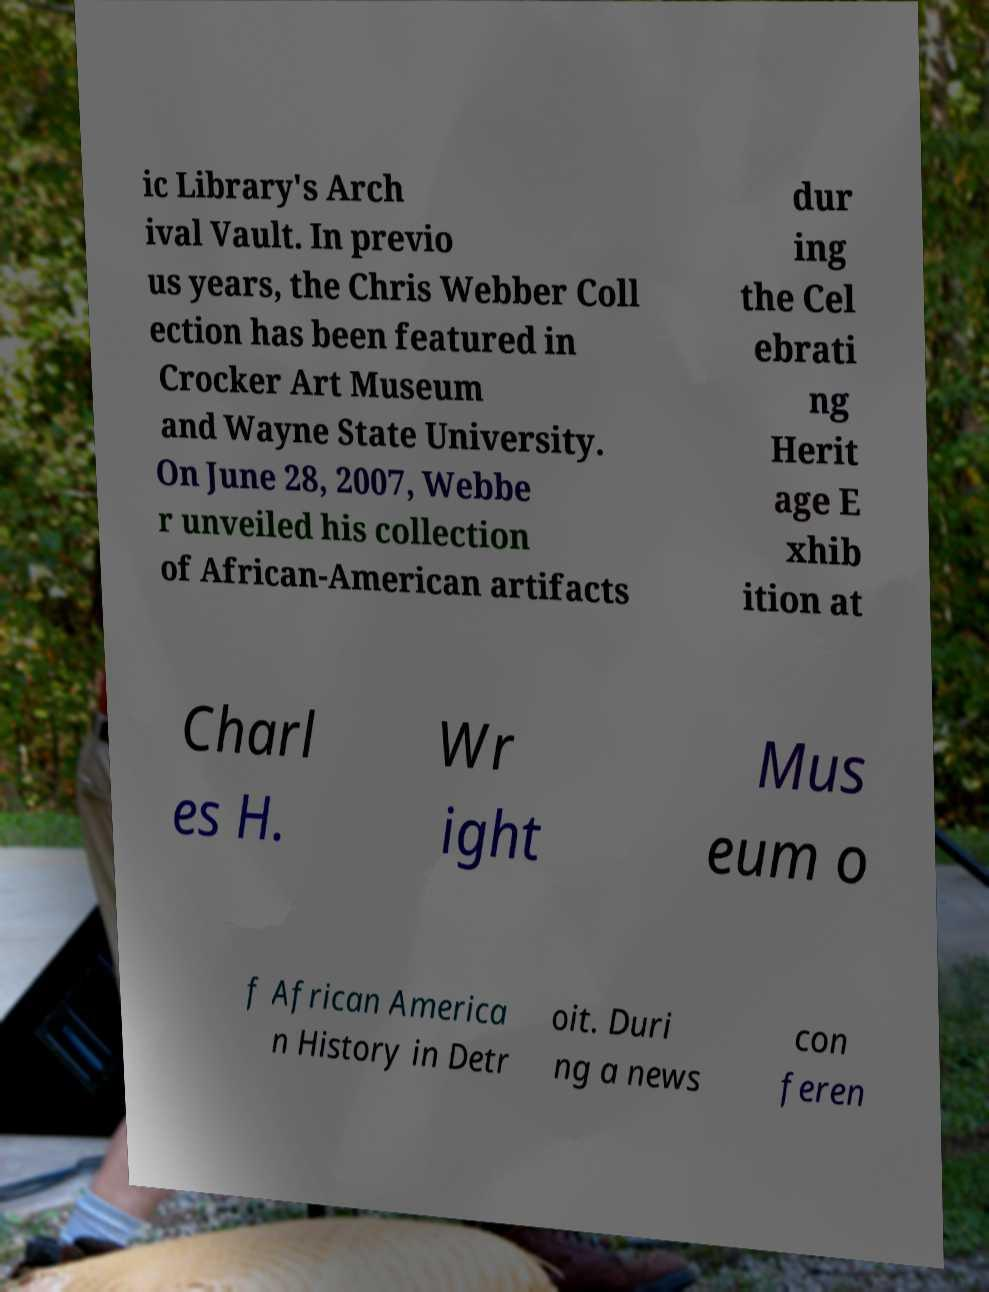Can you read and provide the text displayed in the image?This photo seems to have some interesting text. Can you extract and type it out for me? ic Library's Arch ival Vault. In previo us years, the Chris Webber Coll ection has been featured in Crocker Art Museum and Wayne State University. On June 28, 2007, Webbe r unveiled his collection of African-American artifacts dur ing the Cel ebrati ng Herit age E xhib ition at Charl es H. Wr ight Mus eum o f African America n History in Detr oit. Duri ng a news con feren 